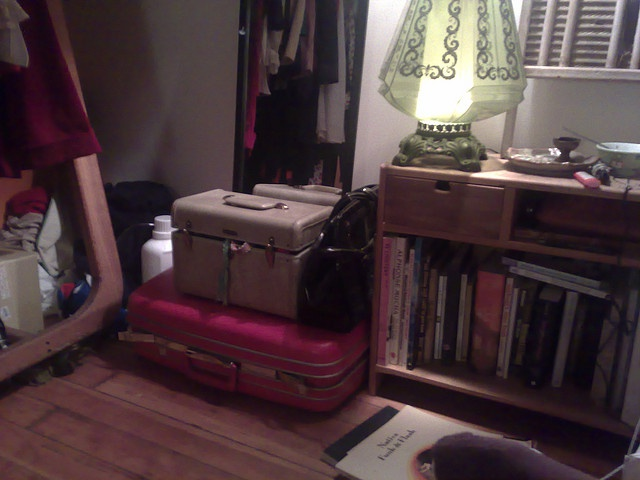Describe the objects in this image and their specific colors. I can see suitcase in black, maroon, and purple tones, suitcase in black, darkgray, and gray tones, handbag in black and gray tones, book in black and gray tones, and book in black and maroon tones in this image. 